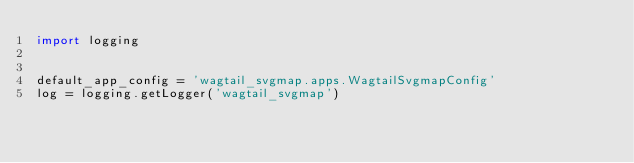<code> <loc_0><loc_0><loc_500><loc_500><_Python_>import logging


default_app_config = 'wagtail_svgmap.apps.WagtailSvgmapConfig'
log = logging.getLogger('wagtail_svgmap')
</code> 